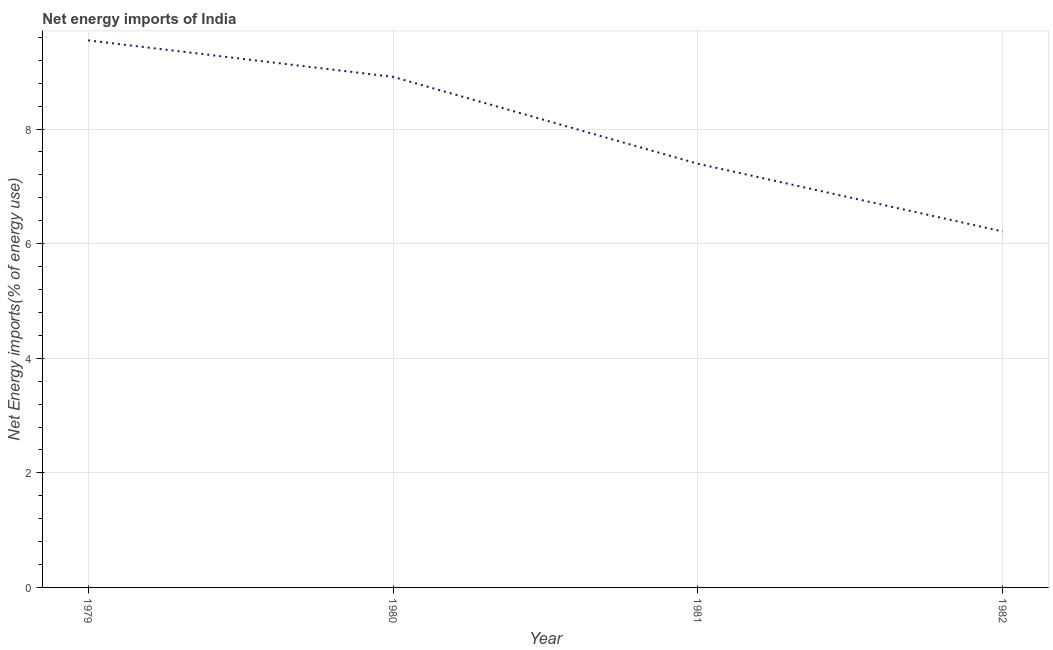What is the energy imports in 1979?
Make the answer very short. 9.55. Across all years, what is the maximum energy imports?
Provide a short and direct response. 9.55. Across all years, what is the minimum energy imports?
Your answer should be very brief. 6.21. In which year was the energy imports maximum?
Keep it short and to the point. 1979. In which year was the energy imports minimum?
Your response must be concise. 1982. What is the sum of the energy imports?
Offer a very short reply. 32.07. What is the difference between the energy imports in 1980 and 1981?
Your response must be concise. 1.52. What is the average energy imports per year?
Your answer should be very brief. 8.02. What is the median energy imports?
Your answer should be very brief. 8.15. Do a majority of the years between 1979 and 1981 (inclusive) have energy imports greater than 2 %?
Give a very brief answer. Yes. What is the ratio of the energy imports in 1980 to that in 1981?
Give a very brief answer. 1.21. What is the difference between the highest and the second highest energy imports?
Provide a short and direct response. 0.64. What is the difference between the highest and the lowest energy imports?
Make the answer very short. 3.34. In how many years, is the energy imports greater than the average energy imports taken over all years?
Your answer should be compact. 2. How many lines are there?
Provide a short and direct response. 1. What is the title of the graph?
Provide a succinct answer. Net energy imports of India. What is the label or title of the Y-axis?
Offer a terse response. Net Energy imports(% of energy use). What is the Net Energy imports(% of energy use) of 1979?
Your answer should be very brief. 9.55. What is the Net Energy imports(% of energy use) of 1980?
Ensure brevity in your answer.  8.91. What is the Net Energy imports(% of energy use) of 1981?
Offer a terse response. 7.39. What is the Net Energy imports(% of energy use) in 1982?
Make the answer very short. 6.21. What is the difference between the Net Energy imports(% of energy use) in 1979 and 1980?
Ensure brevity in your answer.  0.64. What is the difference between the Net Energy imports(% of energy use) in 1979 and 1981?
Provide a short and direct response. 2.15. What is the difference between the Net Energy imports(% of energy use) in 1979 and 1982?
Provide a succinct answer. 3.34. What is the difference between the Net Energy imports(% of energy use) in 1980 and 1981?
Ensure brevity in your answer.  1.52. What is the difference between the Net Energy imports(% of energy use) in 1980 and 1982?
Offer a very short reply. 2.7. What is the difference between the Net Energy imports(% of energy use) in 1981 and 1982?
Your answer should be very brief. 1.18. What is the ratio of the Net Energy imports(% of energy use) in 1979 to that in 1980?
Your answer should be compact. 1.07. What is the ratio of the Net Energy imports(% of energy use) in 1979 to that in 1981?
Your response must be concise. 1.29. What is the ratio of the Net Energy imports(% of energy use) in 1979 to that in 1982?
Your answer should be compact. 1.54. What is the ratio of the Net Energy imports(% of energy use) in 1980 to that in 1981?
Provide a short and direct response. 1.21. What is the ratio of the Net Energy imports(% of energy use) in 1980 to that in 1982?
Your response must be concise. 1.43. What is the ratio of the Net Energy imports(% of energy use) in 1981 to that in 1982?
Your answer should be very brief. 1.19. 